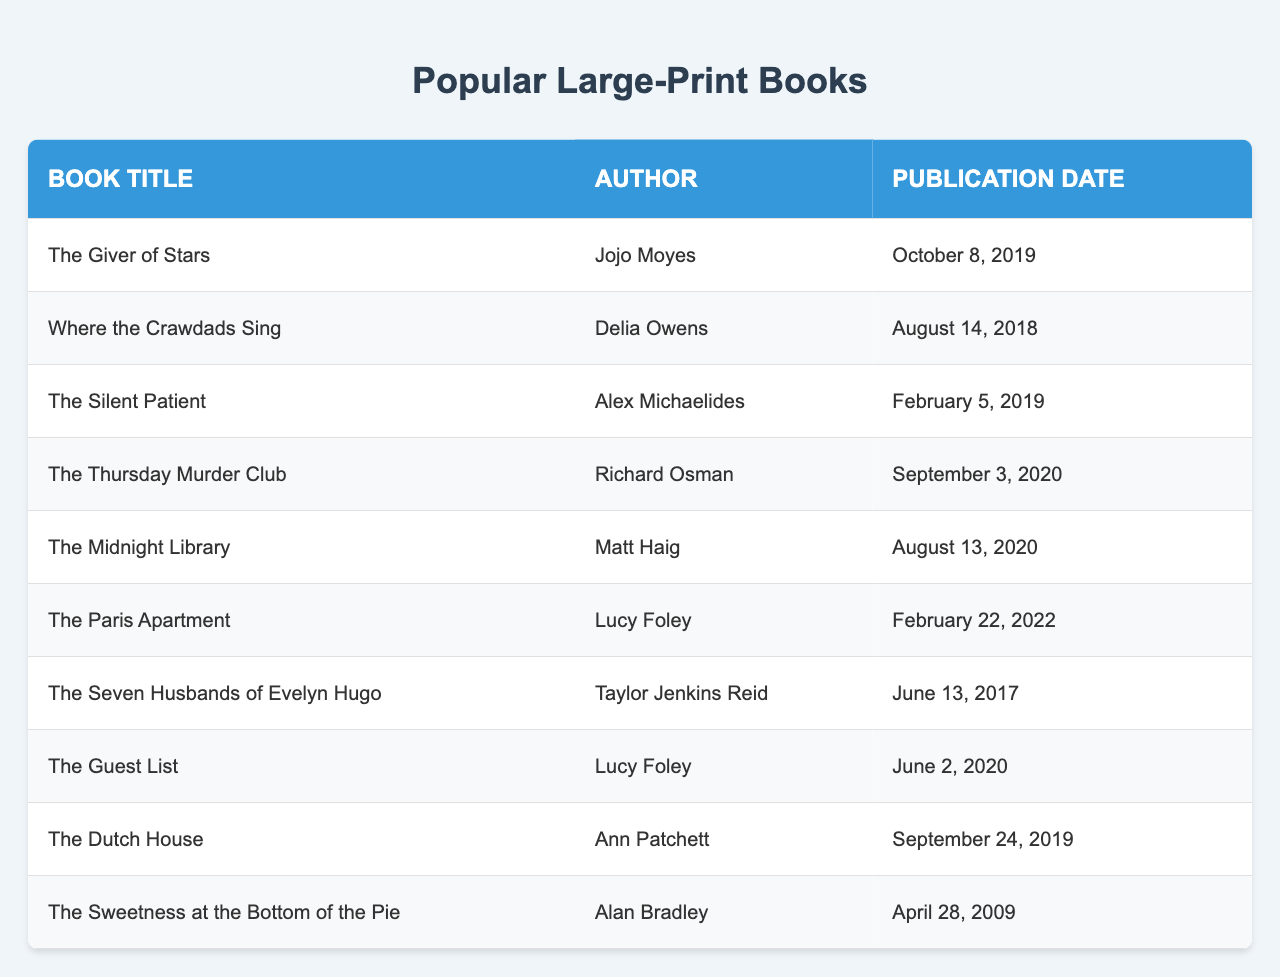What is the title of the book written by Jojo Moyes? The title of the book is located in the row where Jojo Moyes is listed as the author. Looking at that row, the title is "The Giver of Stars."
Answer: The Giver of Stars Which book was published on February 22, 2022? To find the publication date of February 22, 2022, scan through the publication dates in the table. The corresponding title in that row is "The Paris Apartment."
Answer: The Paris Apartment Who is the author of "Where the Crawdads Sing"? The title "Where the Crawdads Sing" can be found in the table, and the author associated with that title is listed directly next to it. The author is Delia Owens.
Answer: Delia Owens What was the publication date of "The Midnight Library"? Locate "The Midnight Library" in the table and look at the publication date associated with it. It shows August 13, 2020.
Answer: August 13, 2020 How many books were published in 2019? Count the rows in the table with publication dates in 2019. The books are "The Silent Patient," "The Giver of Stars," and "The Dutch House." This makes a total of 3 books published in that year.
Answer: 3 Is "The Sweetness at the Bottom of the Pie" authored by Alan Bradley? Check the table for the title "The Sweetness at the Bottom of the Pie" and see if Alan Bradley is listed as the author next to it. The data confirms that it is indeed authored by Alan Bradley.
Answer: Yes Which book published in 2020 has the title that implies a club theme? Review the books published in 2020 in the table. "The Thursday Murder Club" matches the theme of a club. Hence, the title is "The Thursday Murder Club."
Answer: The Thursday Murder Club Who is the author of the most recently published book listed in the table? Identify the most recent publication date in the table, which is February 22, 2022, and find the corresponding author next to it. The author of "The Paris Apartment" is Lucy Foley.
Answer: Lucy Foley What is the title of the book by Matt Haig? Search for Matt Haig's name in the author column. The book listed next to it is "The Midnight Library."
Answer: The Midnight Library What difference in years exists between the publication dates of "The Seven Husbands of Evelyn Hugo" and "Where the Crawdads Sing"? Check the publication years of both books: "The Seven Husbands of Evelyn Hugo" was published in 2017, and "Where the Crawdads Sing" was published in 2018. The difference is 2018 - 2017 = 1 year.
Answer: 1 year 